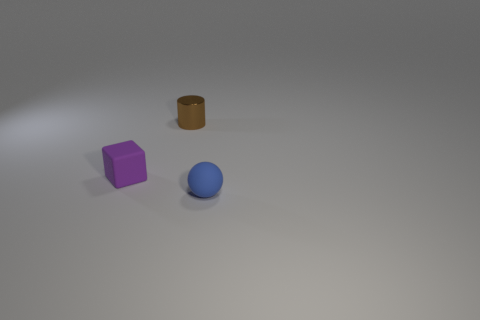What number of other things are there of the same material as the brown object
Ensure brevity in your answer.  0. Do the thing that is to the right of the brown thing and the thing that is on the left side of the small brown object have the same size?
Provide a succinct answer. Yes. How many things are small brown cylinders that are to the right of the purple block or matte objects to the right of the rubber block?
Offer a terse response. 2. Is there anything else that is the same shape as the tiny brown shiny object?
Your response must be concise. No. How many metal things are purple objects or small cylinders?
Make the answer very short. 1. What shape is the rubber object right of the tiny matte object that is behind the blue rubber object?
Your answer should be compact. Sphere. Does the tiny thing to the left of the brown metallic object have the same material as the thing that is in front of the purple block?
Offer a very short reply. Yes. There is a object behind the tiny purple rubber object; how many tiny brown things are on the right side of it?
Offer a terse response. 0. There is a small matte thing behind the object right of the cylinder; what is its color?
Your answer should be very brief. Purple. What is the shape of the blue object?
Give a very brief answer. Sphere. 